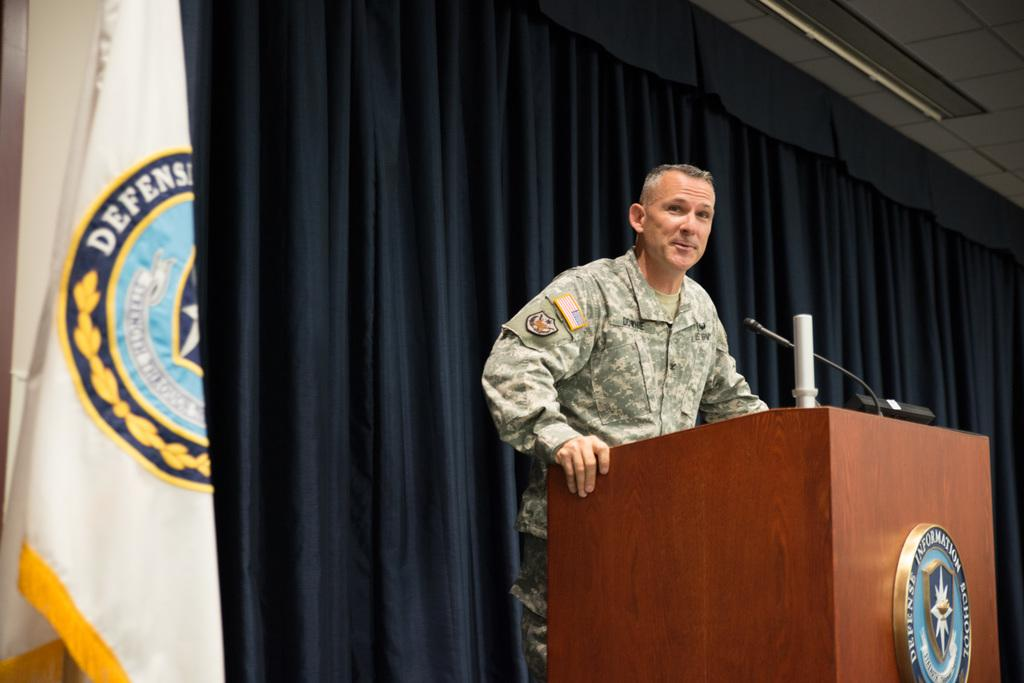What is the man in the image doing? The man is standing behind a podium. What is on the podium with the man? There is a microphone and other things on the podium. What can be seen behind the man? There is a curtain, a flag, and a wall behind the man. How many clovers are on the podium in the image? There are no clovers present in the image. What type of game is the man playing in the image? The man is not playing a game in the image; he is standing behind a podium. 